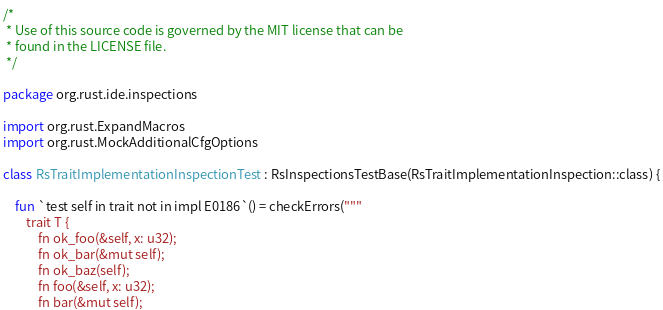Convert code to text. <code><loc_0><loc_0><loc_500><loc_500><_Kotlin_>/*
 * Use of this source code is governed by the MIT license that can be
 * found in the LICENSE file.
 */

package org.rust.ide.inspections

import org.rust.ExpandMacros
import org.rust.MockAdditionalCfgOptions

class RsTraitImplementationInspectionTest : RsInspectionsTestBase(RsTraitImplementationInspection::class) {

    fun `test self in trait not in impl E0186`() = checkErrors("""
        trait T {
            fn ok_foo(&self, x: u32);
            fn ok_bar(&mut self);
            fn ok_baz(self);
            fn foo(&self, x: u32);
            fn bar(&mut self);</code> 